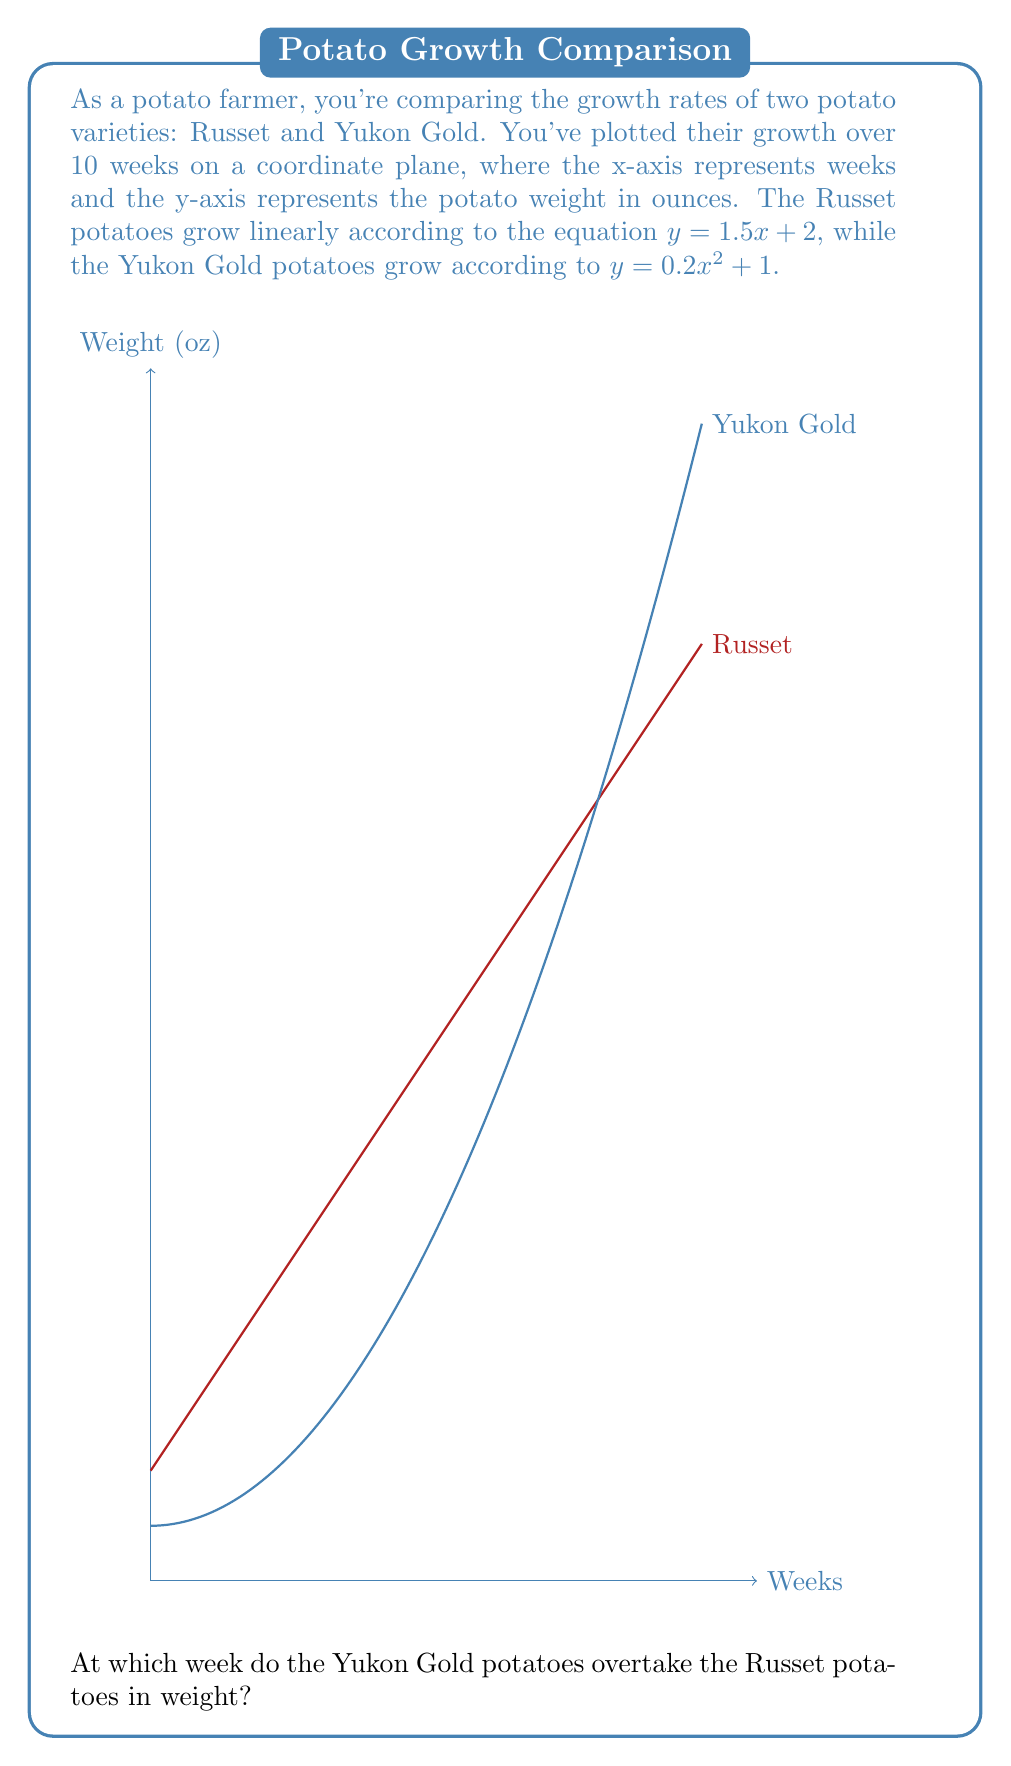Show me your answer to this math problem. Let's approach this step-by-step:

1) We need to find the point where the two equations intersect. This occurs when:

   $1.5x + 2 = 0.2x^2 + 1$

2) Rearrange the equation:
   
   $0.2x^2 - 1.5x - 1 = 0$

3) This is a quadratic equation in the form $ax^2 + bx + c = 0$, where:
   $a = 0.2$, $b = -1.5$, and $c = -1$

4) We can solve this using the quadratic formula: $x = \frac{-b \pm \sqrt{b^2 - 4ac}}{2a}$

5) Plugging in our values:

   $x = \frac{1.5 \pm \sqrt{(-1.5)^2 - 4(0.2)(-1)}}{2(0.2)}$

6) Simplify:

   $x = \frac{1.5 \pm \sqrt{2.25 + 0.8}}{0.4} = \frac{1.5 \pm \sqrt{3.05}}{0.4}$

7) Calculate:

   $x \approx 6.37$ or $x \approx -1.37$

8) Since we're dealing with weeks, we can discard the negative solution.

9) The intersection occurs at approximately 6.37 weeks.

10) Since we're asked for the week when Yukon Gold overtakes Russet, we need to round up to the next whole week.

Therefore, Yukon Gold potatoes overtake Russet potatoes in weight during the 7th week.
Answer: 7th week 